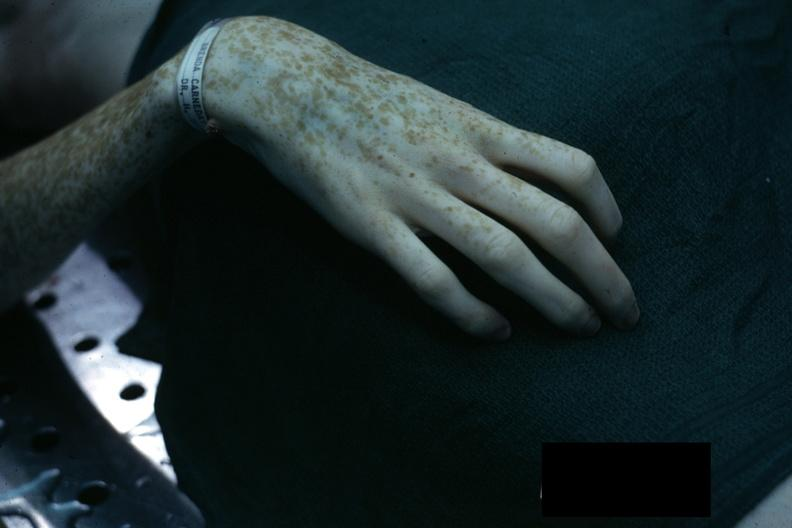re gangrene fingers present?
Answer the question using a single word or phrase. No 